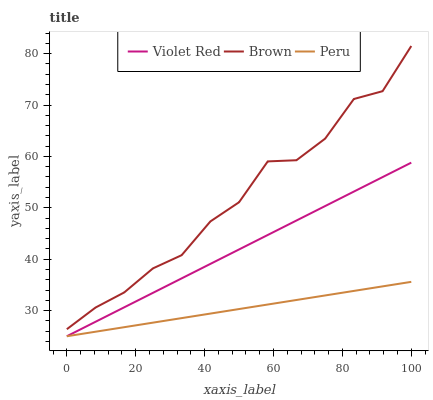Does Peru have the minimum area under the curve?
Answer yes or no. Yes. Does Brown have the maximum area under the curve?
Answer yes or no. Yes. Does Violet Red have the minimum area under the curve?
Answer yes or no. No. Does Violet Red have the maximum area under the curve?
Answer yes or no. No. Is Peru the smoothest?
Answer yes or no. Yes. Is Brown the roughest?
Answer yes or no. Yes. Is Violet Red the smoothest?
Answer yes or no. No. Is Violet Red the roughest?
Answer yes or no. No. Does Violet Red have the lowest value?
Answer yes or no. Yes. Does Brown have the highest value?
Answer yes or no. Yes. Does Violet Red have the highest value?
Answer yes or no. No. Is Violet Red less than Brown?
Answer yes or no. Yes. Is Brown greater than Violet Red?
Answer yes or no. Yes. Does Peru intersect Violet Red?
Answer yes or no. Yes. Is Peru less than Violet Red?
Answer yes or no. No. Is Peru greater than Violet Red?
Answer yes or no. No. Does Violet Red intersect Brown?
Answer yes or no. No. 